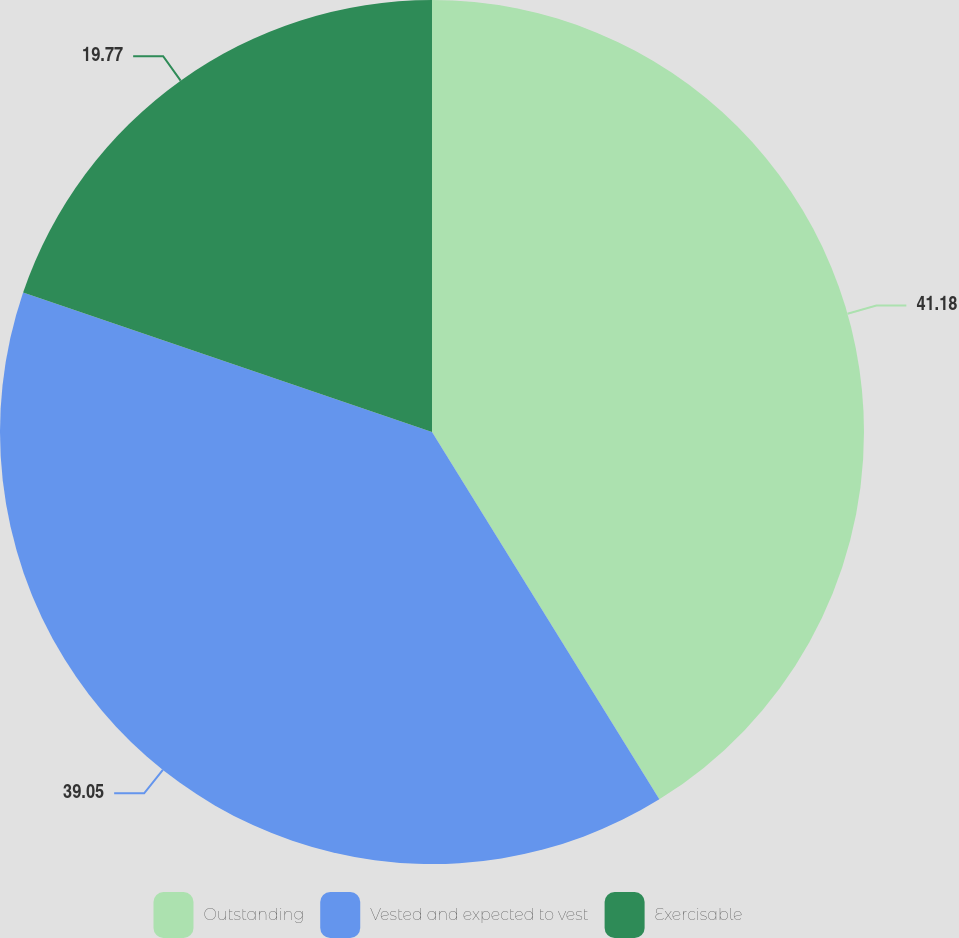Convert chart. <chart><loc_0><loc_0><loc_500><loc_500><pie_chart><fcel>Outstanding<fcel>Vested and expected to vest<fcel>Exercisable<nl><fcel>41.18%<fcel>39.05%<fcel>19.77%<nl></chart> 